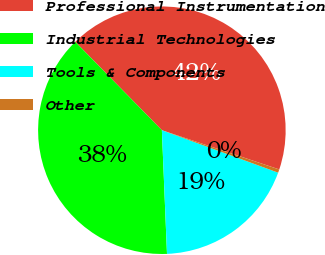Convert chart. <chart><loc_0><loc_0><loc_500><loc_500><pie_chart><fcel>Professional Instrumentation<fcel>Industrial Technologies<fcel>Tools & Components<fcel>Other<nl><fcel>42.47%<fcel>38.32%<fcel>18.77%<fcel>0.44%<nl></chart> 